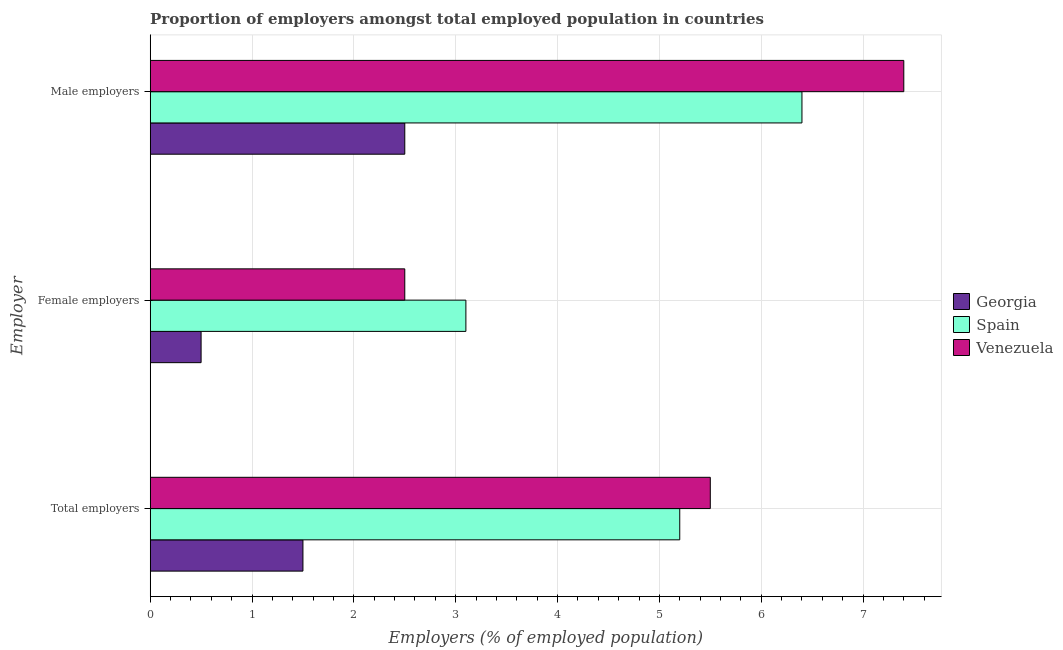Are the number of bars on each tick of the Y-axis equal?
Provide a short and direct response. Yes. How many bars are there on the 3rd tick from the top?
Provide a short and direct response. 3. How many bars are there on the 2nd tick from the bottom?
Your answer should be very brief. 3. What is the label of the 1st group of bars from the top?
Your answer should be compact. Male employers. What is the percentage of male employers in Spain?
Offer a very short reply. 6.4. Across all countries, what is the maximum percentage of female employers?
Your response must be concise. 3.1. Across all countries, what is the minimum percentage of male employers?
Keep it short and to the point. 2.5. In which country was the percentage of total employers maximum?
Make the answer very short. Venezuela. In which country was the percentage of female employers minimum?
Your answer should be very brief. Georgia. What is the total percentage of male employers in the graph?
Offer a terse response. 16.3. What is the difference between the percentage of female employers in Spain and that in Georgia?
Provide a succinct answer. 2.6. What is the difference between the percentage of female employers in Georgia and the percentage of total employers in Spain?
Offer a terse response. -4.7. What is the average percentage of female employers per country?
Keep it short and to the point. 2.03. What is the ratio of the percentage of total employers in Spain to that in Venezuela?
Keep it short and to the point. 0.95. What is the difference between the highest and the second highest percentage of female employers?
Offer a terse response. 0.6. What is the difference between the highest and the lowest percentage of male employers?
Provide a short and direct response. 4.9. Is the sum of the percentage of male employers in Spain and Georgia greater than the maximum percentage of total employers across all countries?
Your response must be concise. Yes. What does the 2nd bar from the top in Total employers represents?
Ensure brevity in your answer.  Spain. Is it the case that in every country, the sum of the percentage of total employers and percentage of female employers is greater than the percentage of male employers?
Give a very brief answer. No. How many bars are there?
Your answer should be very brief. 9. Does the graph contain grids?
Offer a very short reply. Yes. Where does the legend appear in the graph?
Provide a short and direct response. Center right. How many legend labels are there?
Your response must be concise. 3. What is the title of the graph?
Your answer should be compact. Proportion of employers amongst total employed population in countries. What is the label or title of the X-axis?
Provide a succinct answer. Employers (% of employed population). What is the label or title of the Y-axis?
Offer a very short reply. Employer. What is the Employers (% of employed population) in Spain in Total employers?
Provide a succinct answer. 5.2. What is the Employers (% of employed population) of Georgia in Female employers?
Ensure brevity in your answer.  0.5. What is the Employers (% of employed population) of Spain in Female employers?
Give a very brief answer. 3.1. What is the Employers (% of employed population) in Venezuela in Female employers?
Your answer should be compact. 2.5. What is the Employers (% of employed population) of Georgia in Male employers?
Offer a very short reply. 2.5. What is the Employers (% of employed population) of Spain in Male employers?
Provide a short and direct response. 6.4. What is the Employers (% of employed population) in Venezuela in Male employers?
Provide a succinct answer. 7.4. Across all Employer, what is the maximum Employers (% of employed population) in Georgia?
Give a very brief answer. 2.5. Across all Employer, what is the maximum Employers (% of employed population) of Spain?
Provide a short and direct response. 6.4. Across all Employer, what is the maximum Employers (% of employed population) in Venezuela?
Your response must be concise. 7.4. Across all Employer, what is the minimum Employers (% of employed population) in Georgia?
Your response must be concise. 0.5. Across all Employer, what is the minimum Employers (% of employed population) of Spain?
Provide a short and direct response. 3.1. Across all Employer, what is the minimum Employers (% of employed population) of Venezuela?
Keep it short and to the point. 2.5. What is the difference between the Employers (% of employed population) in Spain in Total employers and that in Male employers?
Keep it short and to the point. -1.2. What is the difference between the Employers (% of employed population) of Venezuela in Female employers and that in Male employers?
Make the answer very short. -4.9. What is the difference between the Employers (% of employed population) of Georgia in Total employers and the Employers (% of employed population) of Venezuela in Female employers?
Your answer should be compact. -1. What is the difference between the Employers (% of employed population) of Spain in Total employers and the Employers (% of employed population) of Venezuela in Female employers?
Your answer should be very brief. 2.7. What is the difference between the Employers (% of employed population) of Spain in Total employers and the Employers (% of employed population) of Venezuela in Male employers?
Your answer should be compact. -2.2. What is the difference between the Employers (% of employed population) of Georgia in Female employers and the Employers (% of employed population) of Spain in Male employers?
Ensure brevity in your answer.  -5.9. What is the difference between the Employers (% of employed population) in Georgia in Female employers and the Employers (% of employed population) in Venezuela in Male employers?
Provide a succinct answer. -6.9. What is the average Employers (% of employed population) of Georgia per Employer?
Your answer should be compact. 1.5. What is the average Employers (% of employed population) of Spain per Employer?
Your response must be concise. 4.9. What is the average Employers (% of employed population) in Venezuela per Employer?
Provide a short and direct response. 5.13. What is the difference between the Employers (% of employed population) of Georgia and Employers (% of employed population) of Venezuela in Total employers?
Ensure brevity in your answer.  -4. What is the difference between the Employers (% of employed population) in Georgia and Employers (% of employed population) in Spain in Female employers?
Your answer should be very brief. -2.6. What is the difference between the Employers (% of employed population) of Spain and Employers (% of employed population) of Venezuela in Female employers?
Provide a short and direct response. 0.6. What is the difference between the Employers (% of employed population) of Georgia and Employers (% of employed population) of Venezuela in Male employers?
Provide a succinct answer. -4.9. What is the ratio of the Employers (% of employed population) in Spain in Total employers to that in Female employers?
Provide a short and direct response. 1.68. What is the ratio of the Employers (% of employed population) in Spain in Total employers to that in Male employers?
Your response must be concise. 0.81. What is the ratio of the Employers (% of employed population) in Venezuela in Total employers to that in Male employers?
Make the answer very short. 0.74. What is the ratio of the Employers (% of employed population) of Spain in Female employers to that in Male employers?
Provide a succinct answer. 0.48. What is the ratio of the Employers (% of employed population) of Venezuela in Female employers to that in Male employers?
Your response must be concise. 0.34. What is the difference between the highest and the lowest Employers (% of employed population) in Venezuela?
Provide a succinct answer. 4.9. 